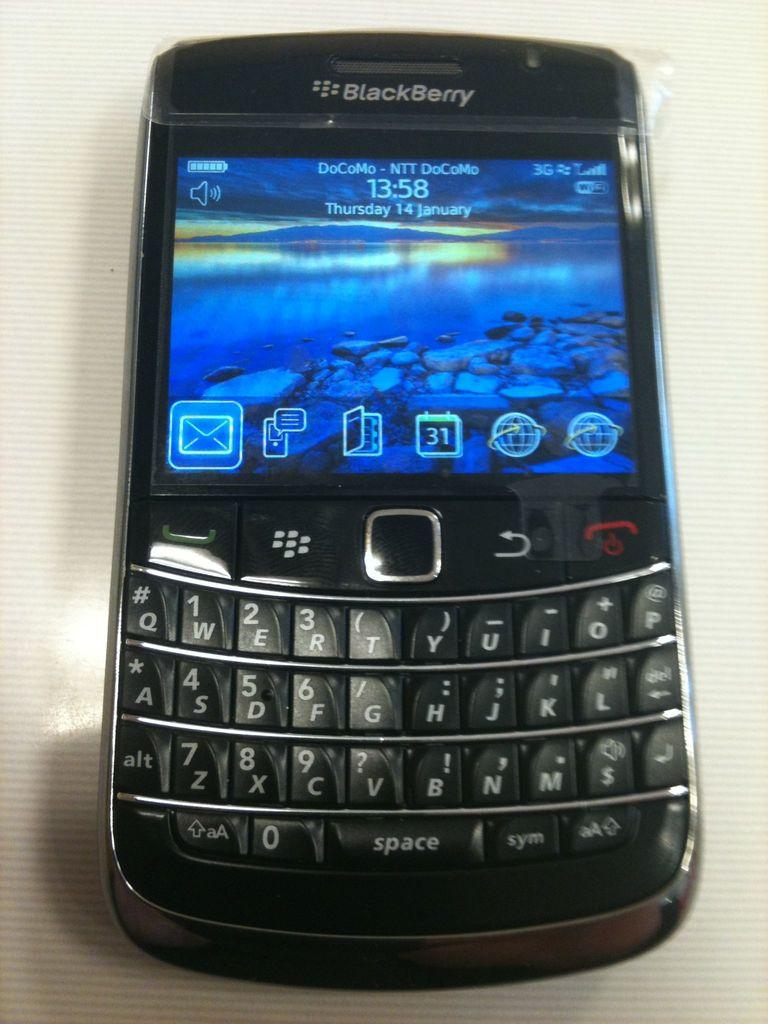<image>
Provide a brief description of the given image. A black BlackBerry is on its home screen. 